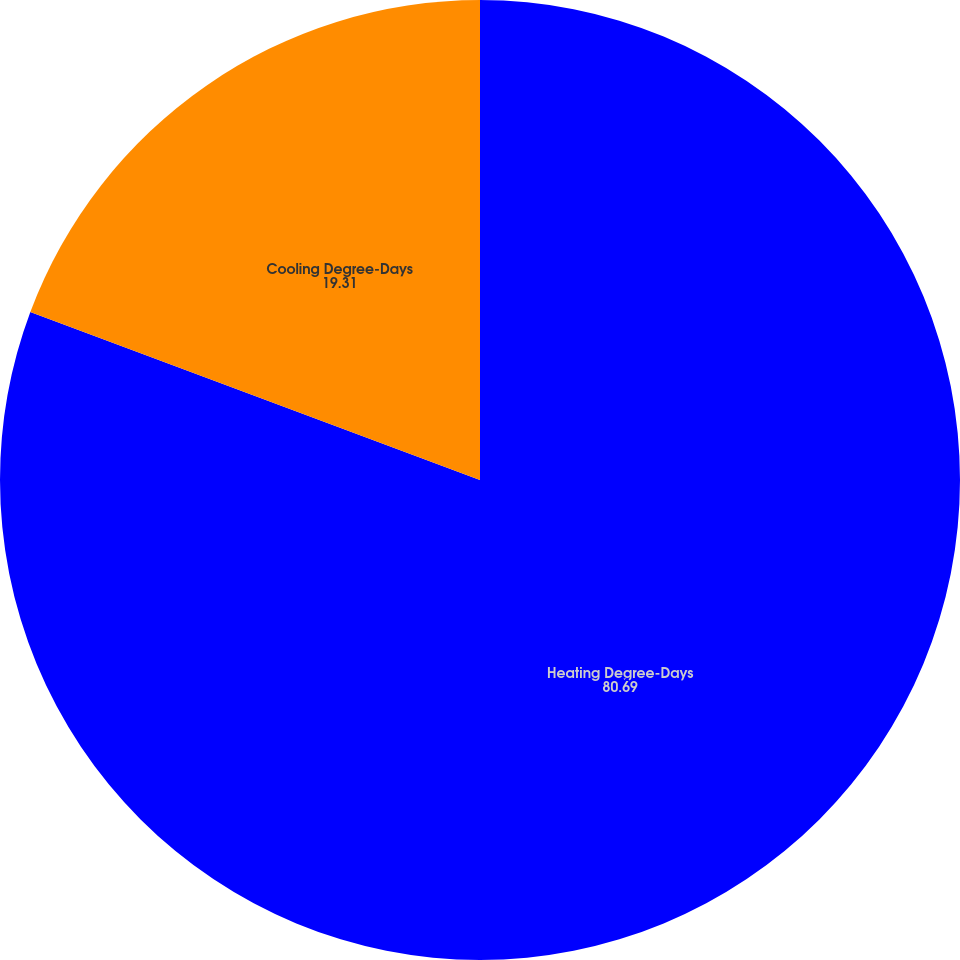Convert chart. <chart><loc_0><loc_0><loc_500><loc_500><pie_chart><fcel>Heating Degree-Days<fcel>Cooling Degree-Days<nl><fcel>80.69%<fcel>19.31%<nl></chart> 